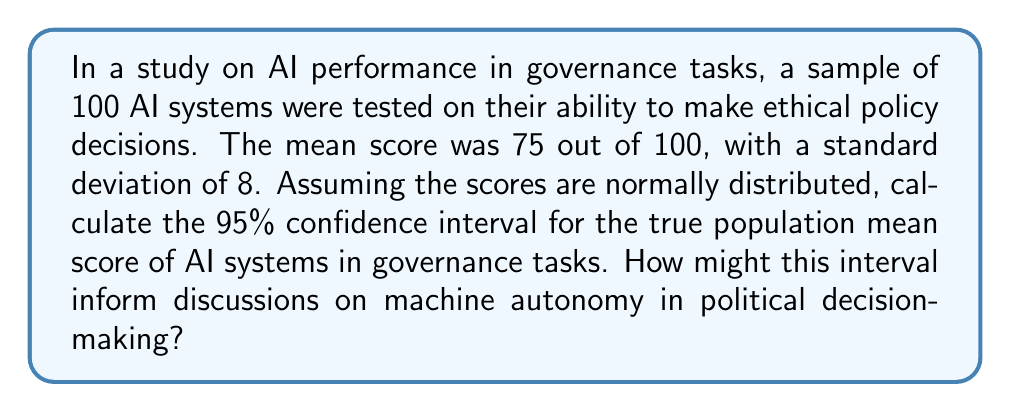Solve this math problem. To calculate the 95% confidence interval for the population mean, we'll use the formula:

$$ \text{CI} = \bar{x} \pm t_{\alpha/2} \cdot \frac{s}{\sqrt{n}} $$

Where:
$\bar{x}$ = sample mean = 75
$s$ = sample standard deviation = 8
$n$ = sample size = 100
$t_{\alpha/2}$ = t-value for 95% confidence interval with 99 degrees of freedom

Steps:
1) For a 95% CI with 99 degrees of freedom, $t_{\alpha/2} \approx 1.984$ (from t-distribution table)

2) Calculate the standard error of the mean:
   $$ SE = \frac{s}{\sqrt{n}} = \frac{8}{\sqrt{100}} = 0.8 $$

3) Calculate the margin of error:
   $$ ME = t_{\alpha/2} \cdot SE = 1.984 \cdot 0.8 = 1.5872 $$

4) Calculate the confidence interval:
   $$ CI = 75 \pm 1.5872 $$
   $$ CI = [73.4128, 76.5872] $$

This interval suggests that we can be 95% confident that the true population mean score for AI systems in governance tasks falls between 73.4128 and 76.5872.

In the context of machine autonomy in political decision-making, this interval provides a quantitative measure of AI performance. It suggests that AI systems, on average, perform relatively well in governance tasks, but there's still room for improvement. This information could inform discussions on the readiness of AI for autonomous political decision-making, the need for further development, and the potential risks and benefits of integrating AI into governance processes.
Answer: The 95% confidence interval for the true population mean score of AI systems in governance tasks is [73.4128, 76.5872]. 